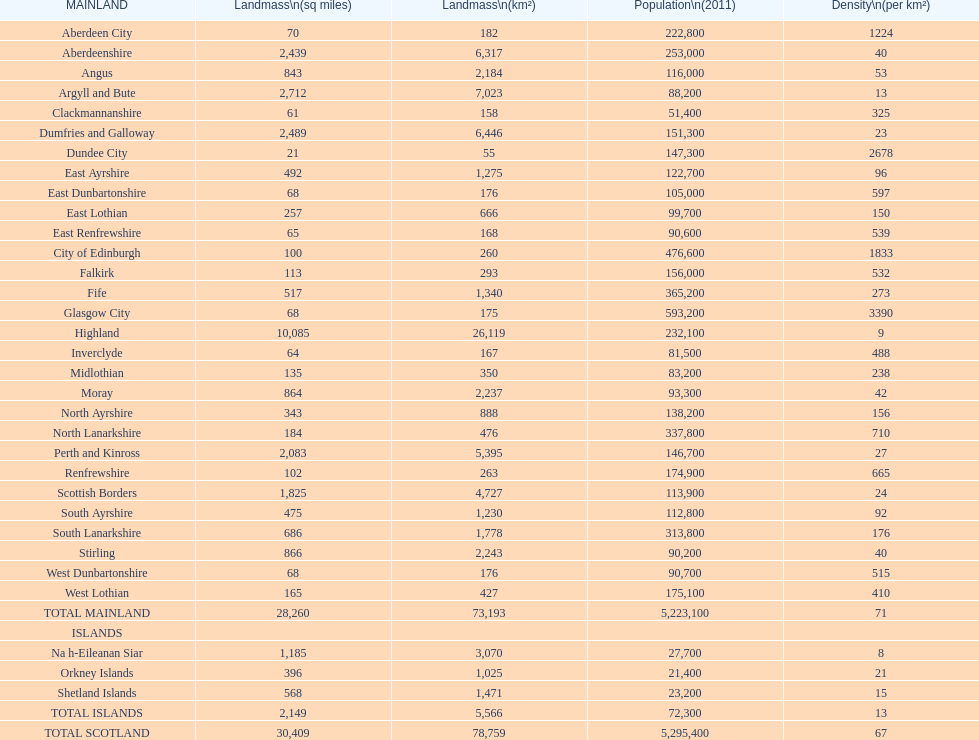What is the difference in square miles from angus and fife? 326. Would you mind parsing the complete table? {'header': ['MAINLAND', 'Landmass\\n(sq miles)', 'Landmass\\n(km²)', 'Population\\n(2011)', 'Density\\n(per km²)'], 'rows': [['Aberdeen City', '70', '182', '222,800', '1224'], ['Aberdeenshire', '2,439', '6,317', '253,000', '40'], ['Angus', '843', '2,184', '116,000', '53'], ['Argyll and Bute', '2,712', '7,023', '88,200', '13'], ['Clackmannanshire', '61', '158', '51,400', '325'], ['Dumfries and Galloway', '2,489', '6,446', '151,300', '23'], ['Dundee City', '21', '55', '147,300', '2678'], ['East Ayrshire', '492', '1,275', '122,700', '96'], ['East Dunbartonshire', '68', '176', '105,000', '597'], ['East Lothian', '257', '666', '99,700', '150'], ['East Renfrewshire', '65', '168', '90,600', '539'], ['City of Edinburgh', '100', '260', '476,600', '1833'], ['Falkirk', '113', '293', '156,000', '532'], ['Fife', '517', '1,340', '365,200', '273'], ['Glasgow City', '68', '175', '593,200', '3390'], ['Highland', '10,085', '26,119', '232,100', '9'], ['Inverclyde', '64', '167', '81,500', '488'], ['Midlothian', '135', '350', '83,200', '238'], ['Moray', '864', '2,237', '93,300', '42'], ['North Ayrshire', '343', '888', '138,200', '156'], ['North Lanarkshire', '184', '476', '337,800', '710'], ['Perth and Kinross', '2,083', '5,395', '146,700', '27'], ['Renfrewshire', '102', '263', '174,900', '665'], ['Scottish Borders', '1,825', '4,727', '113,900', '24'], ['South Ayrshire', '475', '1,230', '112,800', '92'], ['South Lanarkshire', '686', '1,778', '313,800', '176'], ['Stirling', '866', '2,243', '90,200', '40'], ['West Dunbartonshire', '68', '176', '90,700', '515'], ['West Lothian', '165', '427', '175,100', '410'], ['TOTAL MAINLAND', '28,260', '73,193', '5,223,100', '71'], ['ISLANDS', '', '', '', ''], ['Na h-Eileanan Siar', '1,185', '3,070', '27,700', '8'], ['Orkney Islands', '396', '1,025', '21,400', '21'], ['Shetland Islands', '568', '1,471', '23,200', '15'], ['TOTAL ISLANDS', '2,149', '5,566', '72,300', '13'], ['TOTAL SCOTLAND', '30,409', '78,759', '5,295,400', '67']]} 